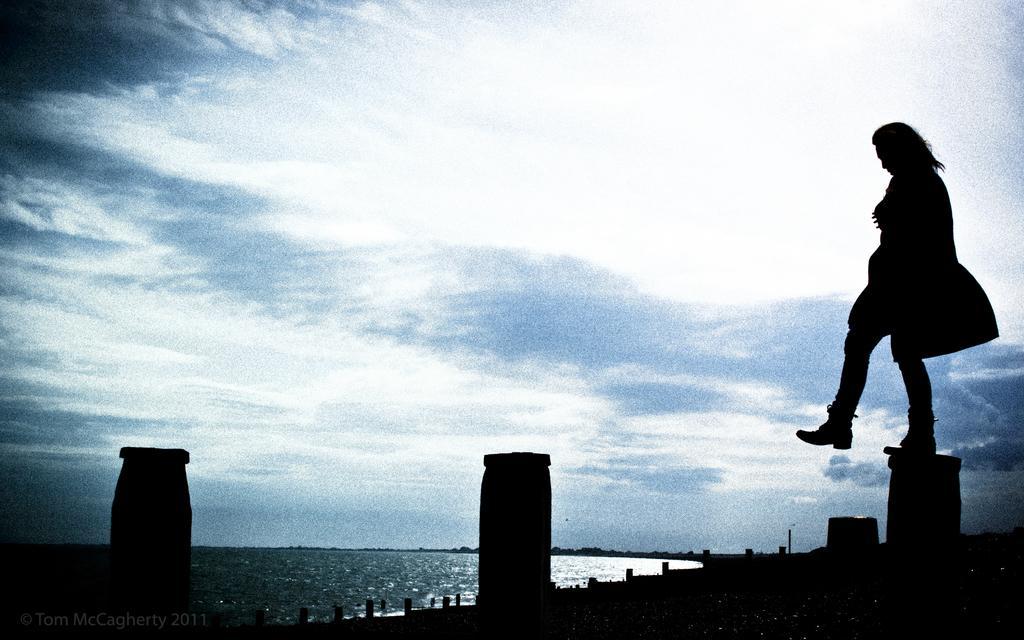Describe this image in one or two sentences. In this image I can see the dark picture in which I can see few poles, a person standing on the pole and the water. In the background I can see the sky. 